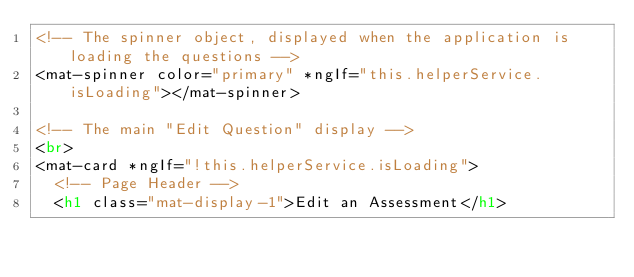Convert code to text. <code><loc_0><loc_0><loc_500><loc_500><_HTML_><!-- The spinner object, displayed when the application is loading the questions -->
<mat-spinner color="primary" *ngIf="this.helperService.isLoading"></mat-spinner>

<!-- The main "Edit Question" display -->
<br>
<mat-card *ngIf="!this.helperService.isLoading">
  <!-- Page Header -->
  <h1 class="mat-display-1">Edit an Assessment</h1>
</code> 